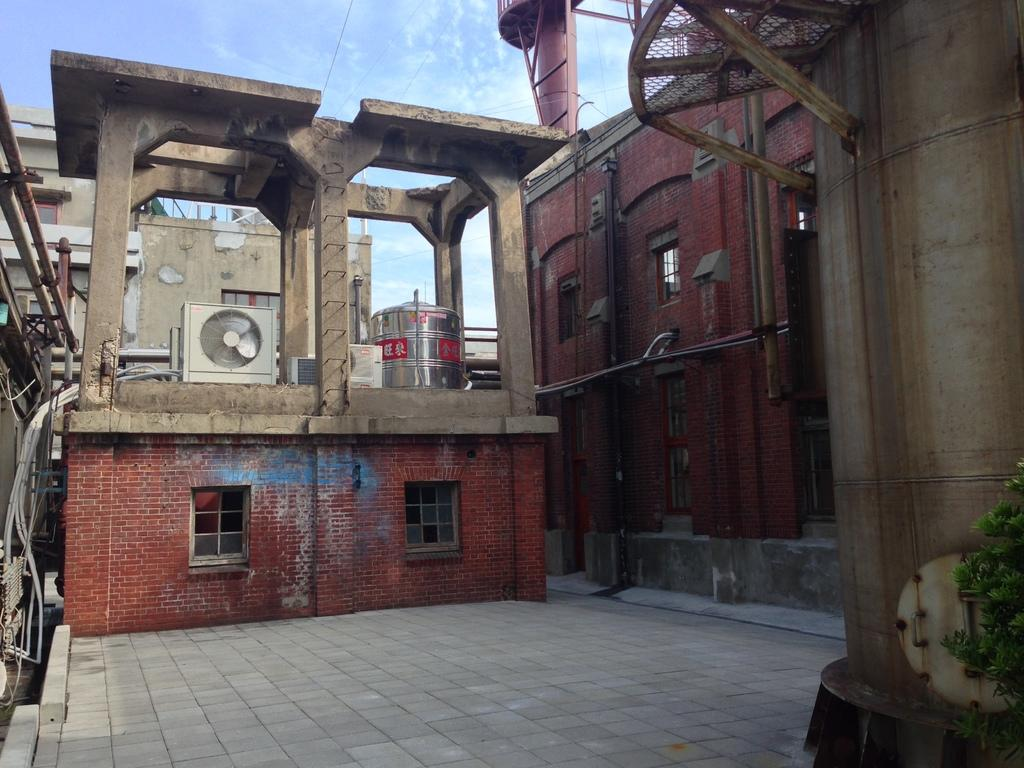What type of structures can be seen in the image? There are buildings in the image. What object made of metal is present in the image? There is a metal tank in the image. What architectural feature is visible in the image? There are windows in the image. What type of equipment is present in the image? There is a condenser in the image. How would you describe the sky in the image? The sky is blue and cloudy in the image. What type of vegetation is present in the image? There is a plant on the right side of the image. How many passengers are visible in the image? There are no passengers present in the image. Is there a person in the image who holds a specific belief? There is no person present in the image, and therefore no beliefs can be attributed to anyone. 